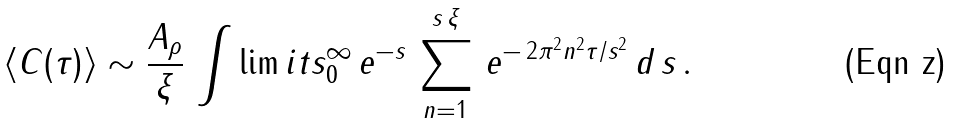Convert formula to latex. <formula><loc_0><loc_0><loc_500><loc_500>\langle C ( \tau ) \rangle \sim \frac { A _ { \rho } } { \xi } \, \int \lim i t s _ { 0 } ^ { \infty } \, e ^ { - s } \, \sum _ { n = 1 } ^ { s \, \xi } \, e ^ { - \, 2 \pi ^ { 2 } n ^ { 2 } \tau / s ^ { 2 } } \, d \, s \, .</formula> 